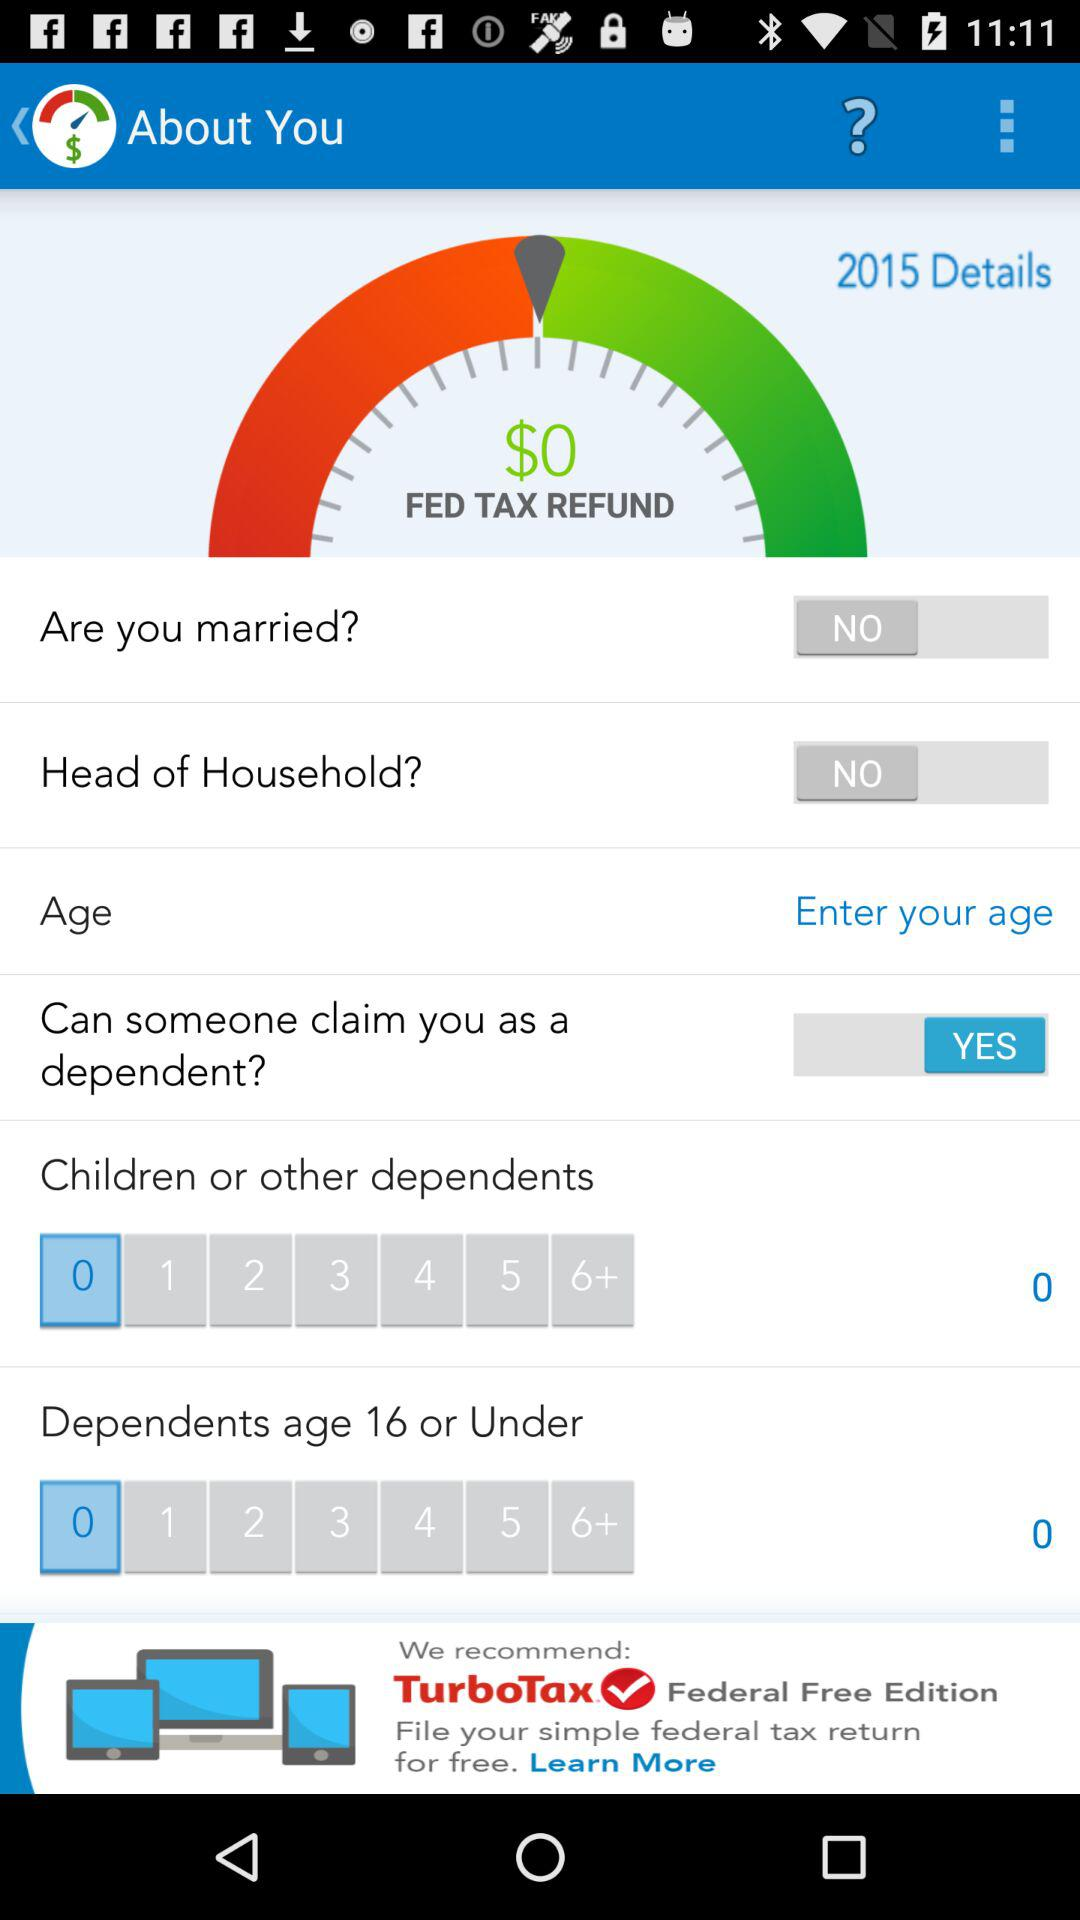What is the Fed Tax Refund? The Fed Tax Refund is $0. 